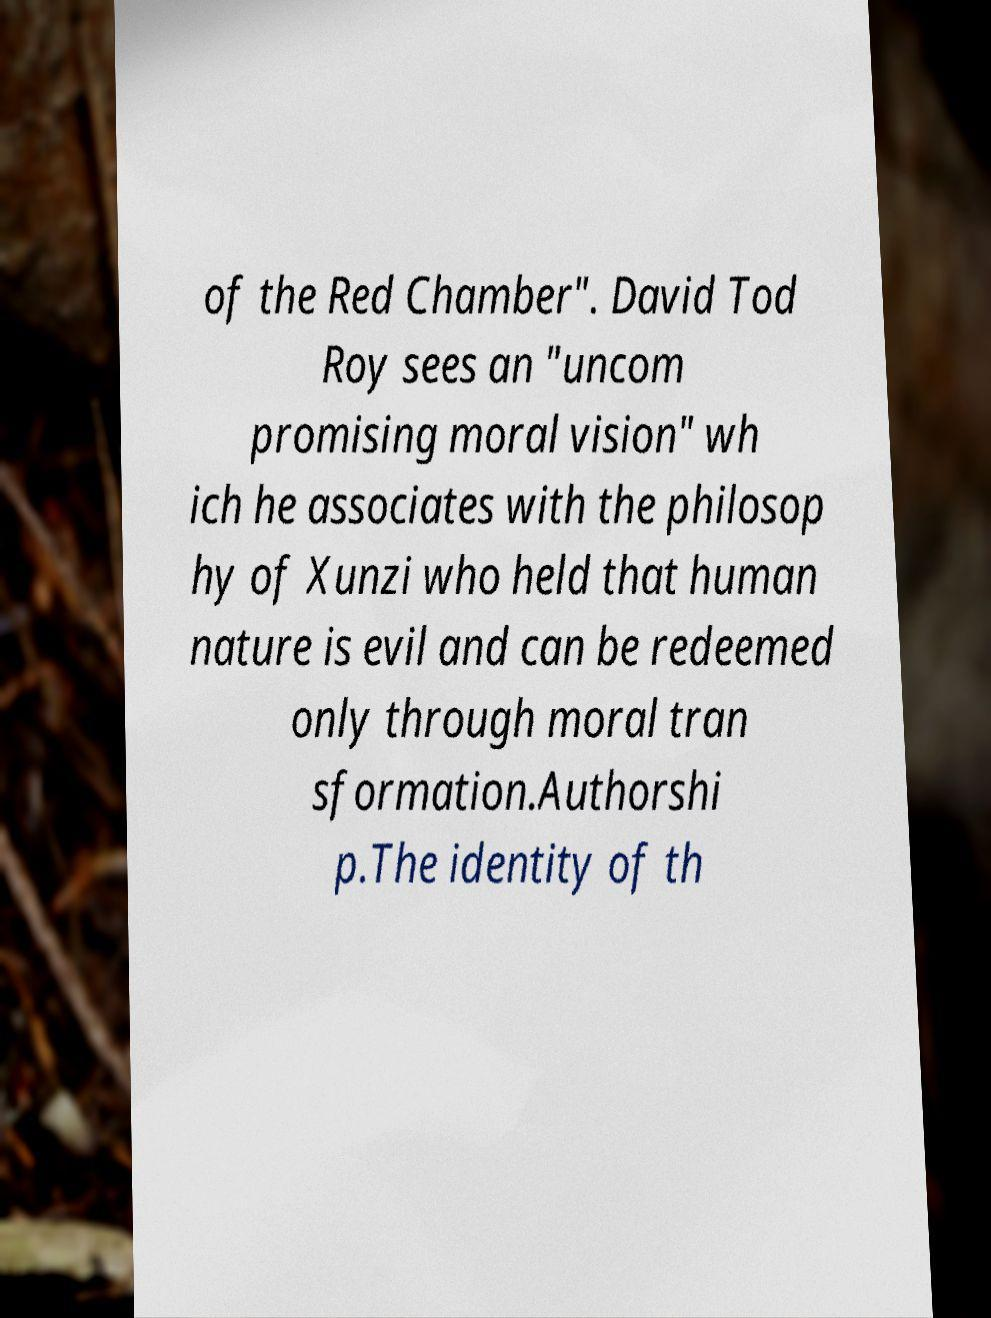Could you assist in decoding the text presented in this image and type it out clearly? of the Red Chamber". David Tod Roy sees an "uncom promising moral vision" wh ich he associates with the philosop hy of Xunzi who held that human nature is evil and can be redeemed only through moral tran sformation.Authorshi p.The identity of th 